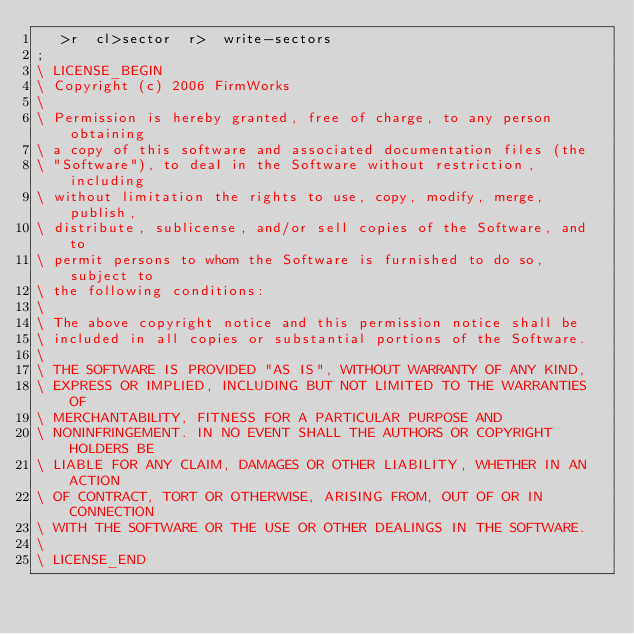Convert code to text. <code><loc_0><loc_0><loc_500><loc_500><_Forth_>   >r  cl>sector  r>  write-sectors
;
\ LICENSE_BEGIN
\ Copyright (c) 2006 FirmWorks
\ 
\ Permission is hereby granted, free of charge, to any person obtaining
\ a copy of this software and associated documentation files (the
\ "Software"), to deal in the Software without restriction, including
\ without limitation the rights to use, copy, modify, merge, publish,
\ distribute, sublicense, and/or sell copies of the Software, and to
\ permit persons to whom the Software is furnished to do so, subject to
\ the following conditions:
\ 
\ The above copyright notice and this permission notice shall be
\ included in all copies or substantial portions of the Software.
\ 
\ THE SOFTWARE IS PROVIDED "AS IS", WITHOUT WARRANTY OF ANY KIND,
\ EXPRESS OR IMPLIED, INCLUDING BUT NOT LIMITED TO THE WARRANTIES OF
\ MERCHANTABILITY, FITNESS FOR A PARTICULAR PURPOSE AND
\ NONINFRINGEMENT. IN NO EVENT SHALL THE AUTHORS OR COPYRIGHT HOLDERS BE
\ LIABLE FOR ANY CLAIM, DAMAGES OR OTHER LIABILITY, WHETHER IN AN ACTION
\ OF CONTRACT, TORT OR OTHERWISE, ARISING FROM, OUT OF OR IN CONNECTION
\ WITH THE SOFTWARE OR THE USE OR OTHER DEALINGS IN THE SOFTWARE.
\
\ LICENSE_END
</code> 